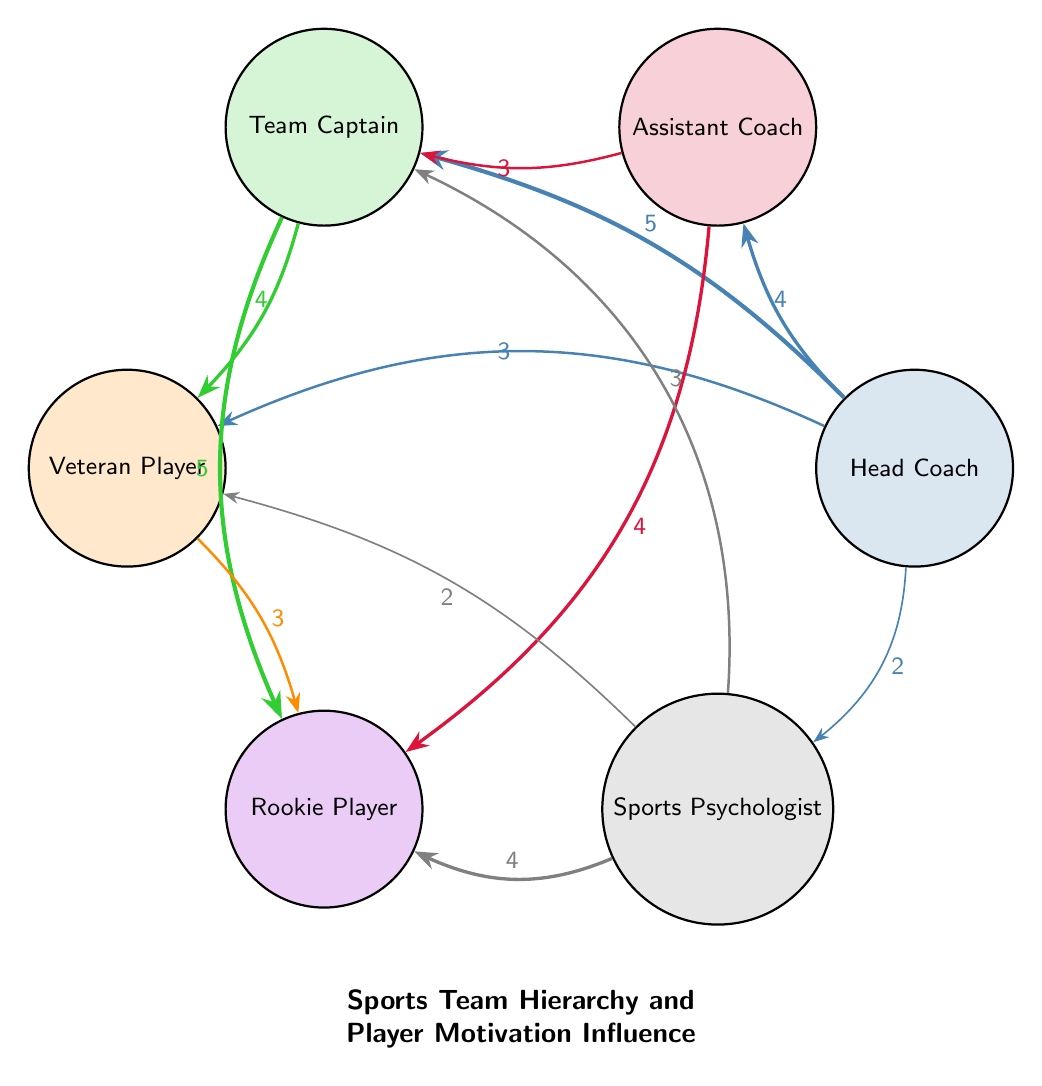How many nodes are in the diagram? The diagram features six distinct nodes: Head Coach, Assistant Coach, Team Captain, Veteran Player, Rookie Player, and Sports Psychologist, therefore counting each unique role gives us a total of six nodes.
Answer: 6 Which node has the highest influence value regarding the Team Captain? To determine this, I look at the outgoing connections from the Team Captain. The highest influence value linked to the Team Captain is the connection to the Rookie Player, which has a value of 5.
Answer: 5 What is the influence value from the Head Coach to the Sports Psychologist? The diagram indicates an influence connection from the Head Coach to the Sports Psychologist with a value of 2, which can be directly seen in the corresponding arrow pointing toward the Sports Psychologist node.
Answer: 2 Which two roles have the same influence value connecting to the Rookie Player? I examine the links connecting to the Rookie Player: the Assistant Coach has a value of 4 and the Team Captain has a value of 5. Since three connections can be drawn to the Rookie Player, I verify that none other share the influence of 4, and thus the only two roles that have an equal influence value regarding connections are the Sports Psychologist and Veteran Player, both of which connect to the Rookie Player for a value of 4.
Answer: Sports Psychologist, Veteran Player What is the total influence value connecting from the Head Coach to all players? First, I tally the influence values of the direct connections from the Head Coach to each connected node: Assistant Coach (4) + Team Captain (5) + Veteran Player (3) + Sports Psychologist (2). Hence, the total sum of these values gives us 4 + 5 + 3 + 2 = 14.
Answer: 14 Which player role interacts the most with the Rookie Player? By reviewing the connections to the Rookie Player, it can be observed that the Team Captain connects with the Rookie Player with an influence value of 5, and the Assistant Coach connects with a value of 4. However, since we are looking for the most significant interaction, the Team Captain is the one with the highest influence value.
Answer: Team Captain What is the lowest influence value between Veteran Player and any player? Analyzing the connections from the Veteran Player, the connections indicate an influence value of 3 towards both the Rookie Player and the Sports Psychologist. Since those are the only two connections made, and given they share the same value of 3, thus it’s the lowest influence observed for the Veteran Player.
Answer: 3 Which role plays a supportive connection to both Veteran and Rookie Players? The connections suggest that the Team Captain plays a supportive role to both the Veteran Player (influence value of 4) and the Rookie Player (influence value of 5). These two connections represent direct support from the Team Captain to both players.
Answer: Team Captain What is the influence value from Sports Psychologist to Veteran Player? Directly reading the diagram, the influence value from Sports Psychologist to the Veteran Player is represented with an arrow indicating a value of 2, which is clearly denoted in the diagram's link.
Answer: 2 How many direct connections link to the Rookie Player? Counting the arrows that point to the Rookie Player, there are four distinct connections: one from the Assistant Coach (value of 4), one from the Team Captain (value of 5), one from the Veteran Player (value of 3), and one from the Sports Psychologist (value of 4), giving us a total of four direct connections.
Answer: 4 